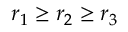Convert formula to latex. <formula><loc_0><loc_0><loc_500><loc_500>r _ { 1 } \geq r _ { 2 } \geq r _ { 3 }</formula> 